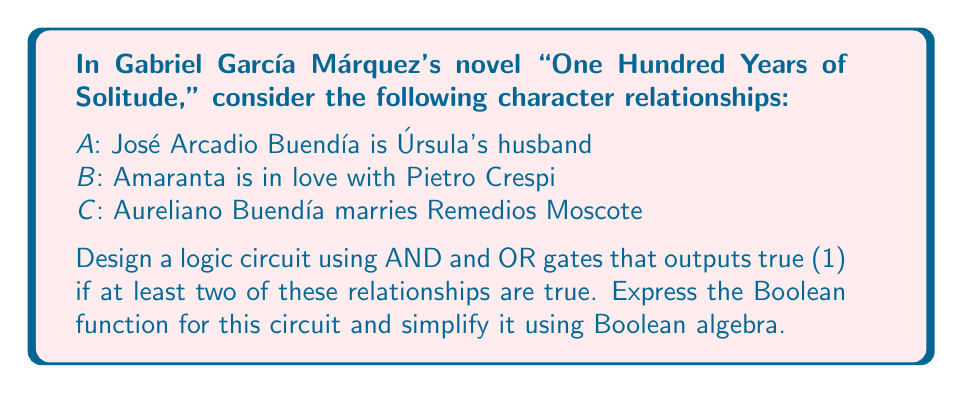Help me with this question. Let's approach this step-by-step:

1) First, we need to create a Boolean function that represents our desired output. We want the function to be true if at least two of A, B, and C are true. This can be expressed as:

   $$ F = AB + AC + BC $$

2) This expression represents all possible combinations where at least two variables are true.

3) To simplify this expression, we can use the distributive law of Boolean algebra:

   $$ F = AB + AC + BC $$
   $$ F = AB + (A+B)C $$

4) Now, let's create a logic circuit for this function:

   [asy]
   import geometry;

   // Define points
   pair A = (0,0), B = (0,30), C = (0,60);
   pair AND1 = (50,15), AND2 = (50,45), OR = (100,30);
   pair out = (150,30);

   // Draw inputs
   draw(A--AND1, arrow=Arrow(TeXHead));
   draw(B--AND1, arrow=Arrow(TeXHead));
   draw(B--(50,30), arrow=Arrow(TeXHead));
   draw(C--AND2, arrow=Arrow(TeXHead));

   // Draw gates
   draw(circle((50,15),10));
   draw(circle((50,45),10));
   draw(circle((100,30),10));

   // Draw connections
   draw(AND1--OR, arrow=Arrow(TeXHead));
   draw(AND2--OR, arrow=Arrow(TeXHead));
   draw(OR--out, arrow=Arrow(TeXHead));

   // Labels
   label("A", A, W);
   label("B", B, W);
   label("C", C, W);
   label("&", (50,15));
   label("&", (50,45));
   label("≥1", (100,30));
   label("F", out, E);
   [/asy]

5) This circuit implements the simplified Boolean function $F = AB + (A+B)C$.

6) The circuit uses two AND gates and one OR gate to achieve the desired logic.
Answer: $F = AB + (A+B)C$ 